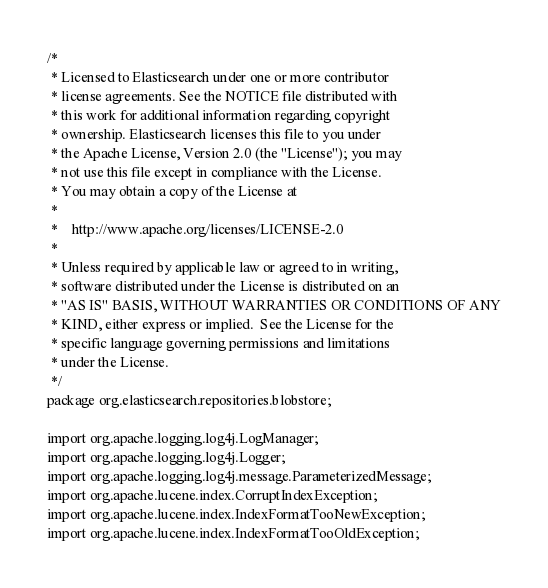Convert code to text. <code><loc_0><loc_0><loc_500><loc_500><_Java_>/*
 * Licensed to Elasticsearch under one or more contributor
 * license agreements. See the NOTICE file distributed with
 * this work for additional information regarding copyright
 * ownership. Elasticsearch licenses this file to you under
 * the Apache License, Version 2.0 (the "License"); you may
 * not use this file except in compliance with the License.
 * You may obtain a copy of the License at
 *
 *    http://www.apache.org/licenses/LICENSE-2.0
 *
 * Unless required by applicable law or agreed to in writing,
 * software distributed under the License is distributed on an
 * "AS IS" BASIS, WITHOUT WARRANTIES OR CONDITIONS OF ANY
 * KIND, either express or implied.  See the License for the
 * specific language governing permissions and limitations
 * under the License.
 */
package org.elasticsearch.repositories.blobstore;

import org.apache.logging.log4j.LogManager;
import org.apache.logging.log4j.Logger;
import org.apache.logging.log4j.message.ParameterizedMessage;
import org.apache.lucene.index.CorruptIndexException;
import org.apache.lucene.index.IndexFormatTooNewException;
import org.apache.lucene.index.IndexFormatTooOldException;</code> 